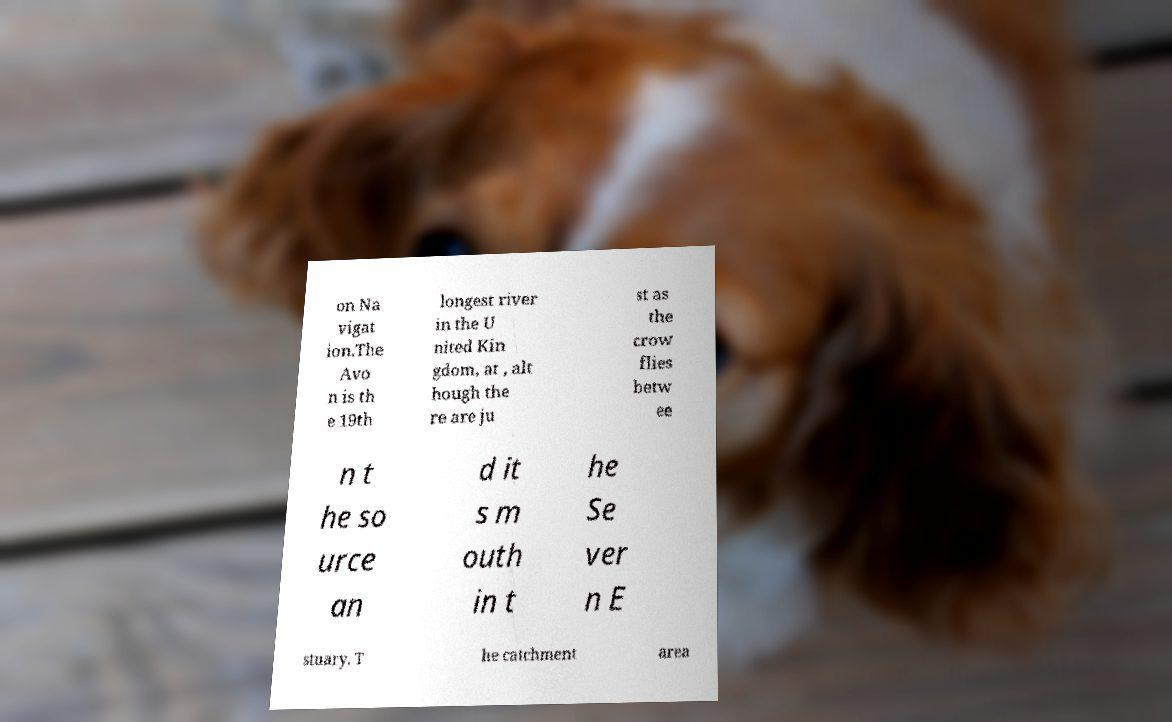Can you accurately transcribe the text from the provided image for me? on Na vigat ion.The Avo n is th e 19th longest river in the U nited Kin gdom, at , alt hough the re are ju st as the crow flies betw ee n t he so urce an d it s m outh in t he Se ver n E stuary. T he catchment area 